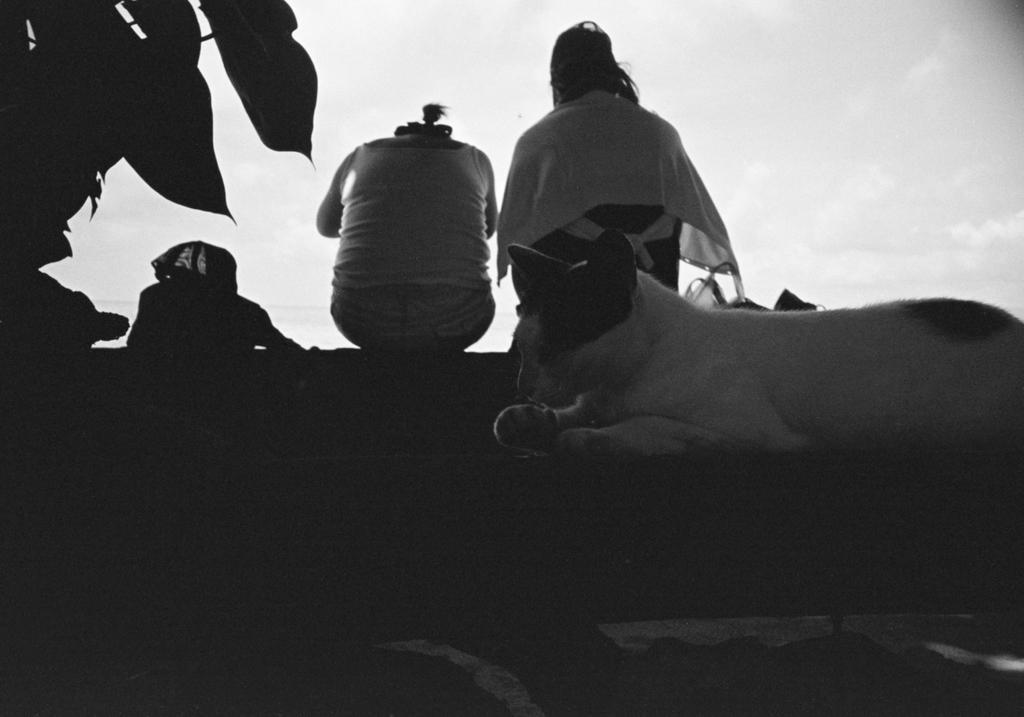How would you summarize this image in a sentence or two? In this image we can see two people sitting and there is a cat. In the background we can see sky. 